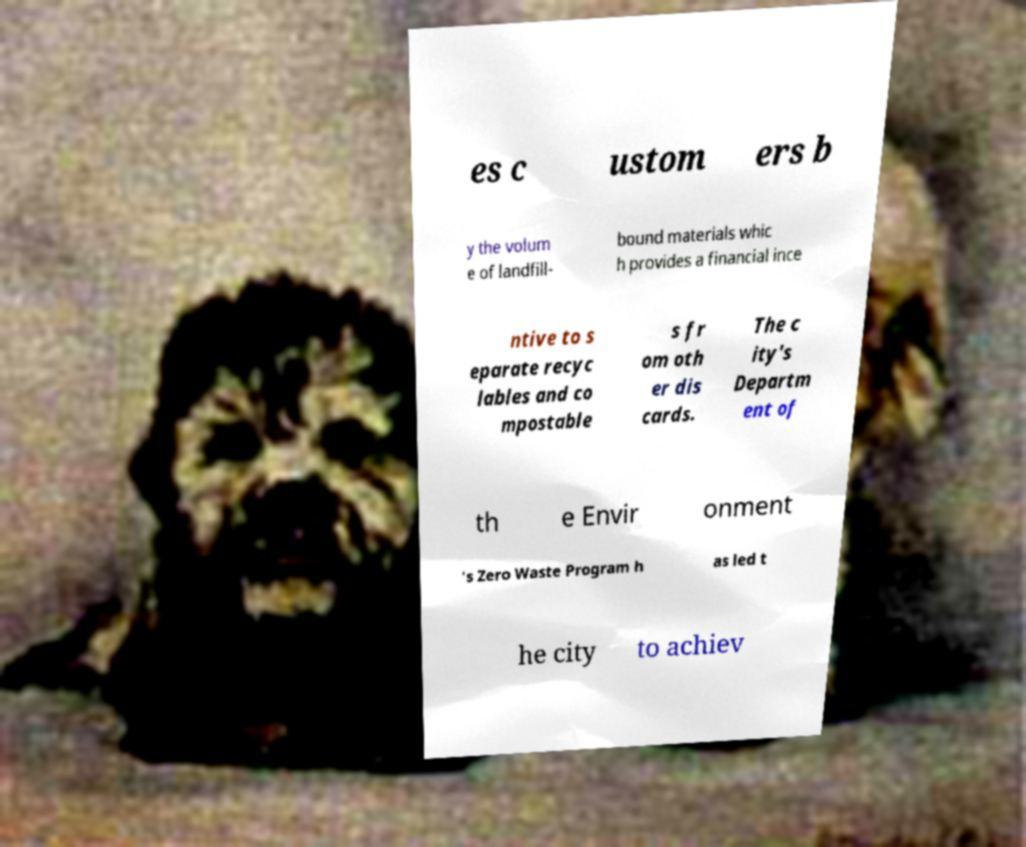I need the written content from this picture converted into text. Can you do that? es c ustom ers b y the volum e of landfill- bound materials whic h provides a financial ince ntive to s eparate recyc lables and co mpostable s fr om oth er dis cards. The c ity's Departm ent of th e Envir onment 's Zero Waste Program h as led t he city to achiev 